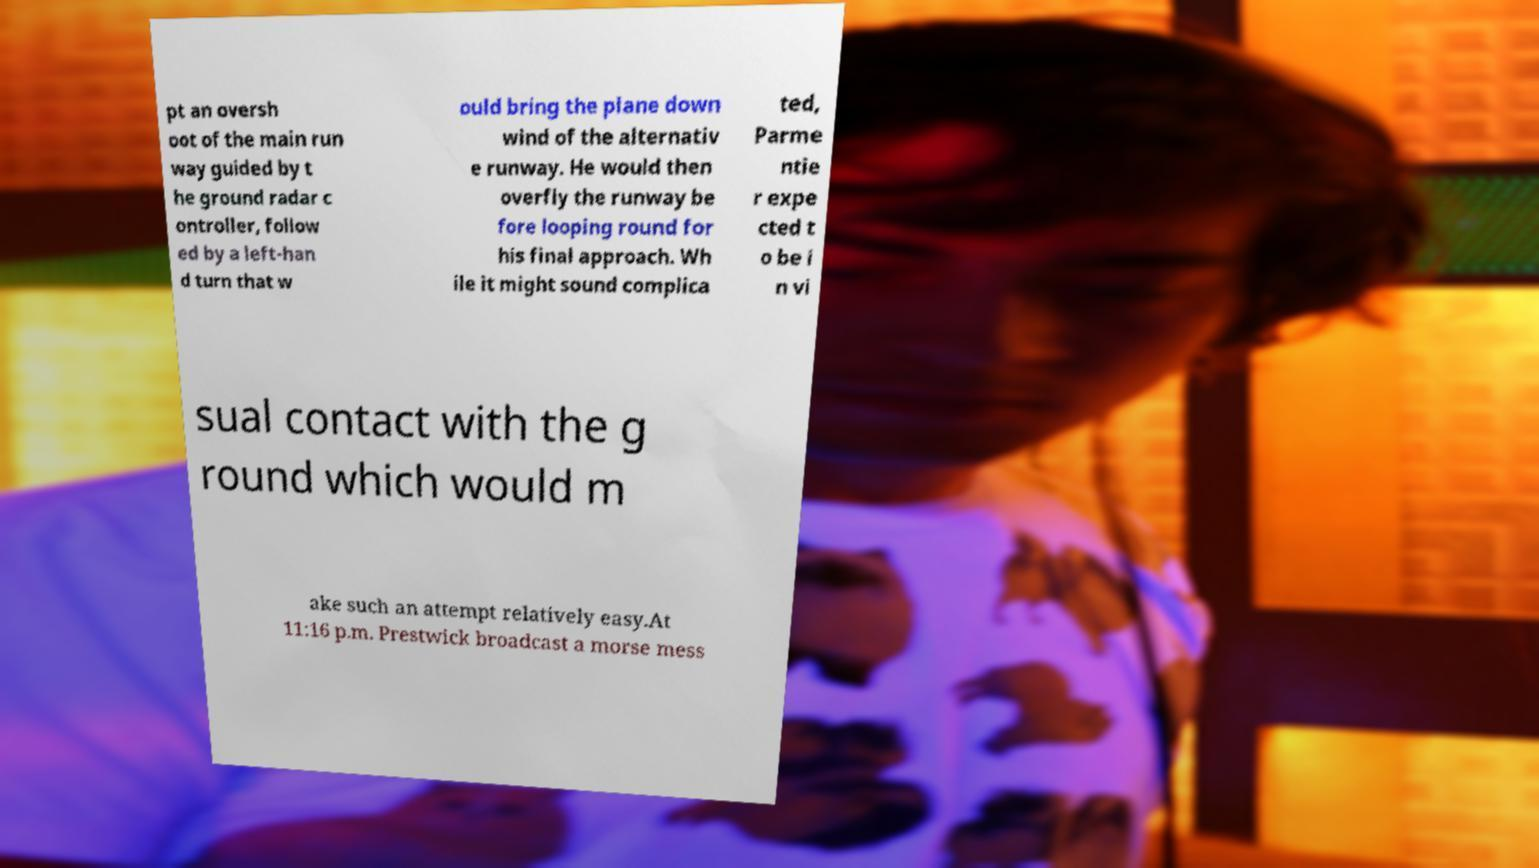Can you accurately transcribe the text from the provided image for me? pt an oversh oot of the main run way guided by t he ground radar c ontroller, follow ed by a left-han d turn that w ould bring the plane down wind of the alternativ e runway. He would then overfly the runway be fore looping round for his final approach. Wh ile it might sound complica ted, Parme ntie r expe cted t o be i n vi sual contact with the g round which would m ake such an attempt relatively easy.At 11:16 p.m. Prestwick broadcast a morse mess 